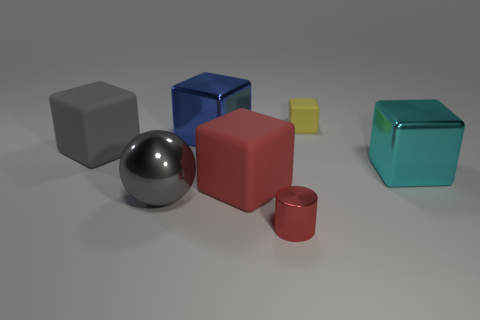Add 2 yellow matte blocks. How many objects exist? 9 Subtract all cyan cubes. How many cubes are left? 4 Subtract all big gray matte blocks. How many blocks are left? 4 Subtract all spheres. How many objects are left? 6 Subtract all green cylinders. Subtract all green spheres. How many cylinders are left? 1 Subtract all blue cylinders. How many blue cubes are left? 1 Subtract all tiny brown rubber spheres. Subtract all tiny yellow rubber objects. How many objects are left? 6 Add 1 cyan cubes. How many cyan cubes are left? 2 Add 3 gray metallic objects. How many gray metallic objects exist? 4 Subtract 1 red blocks. How many objects are left? 6 